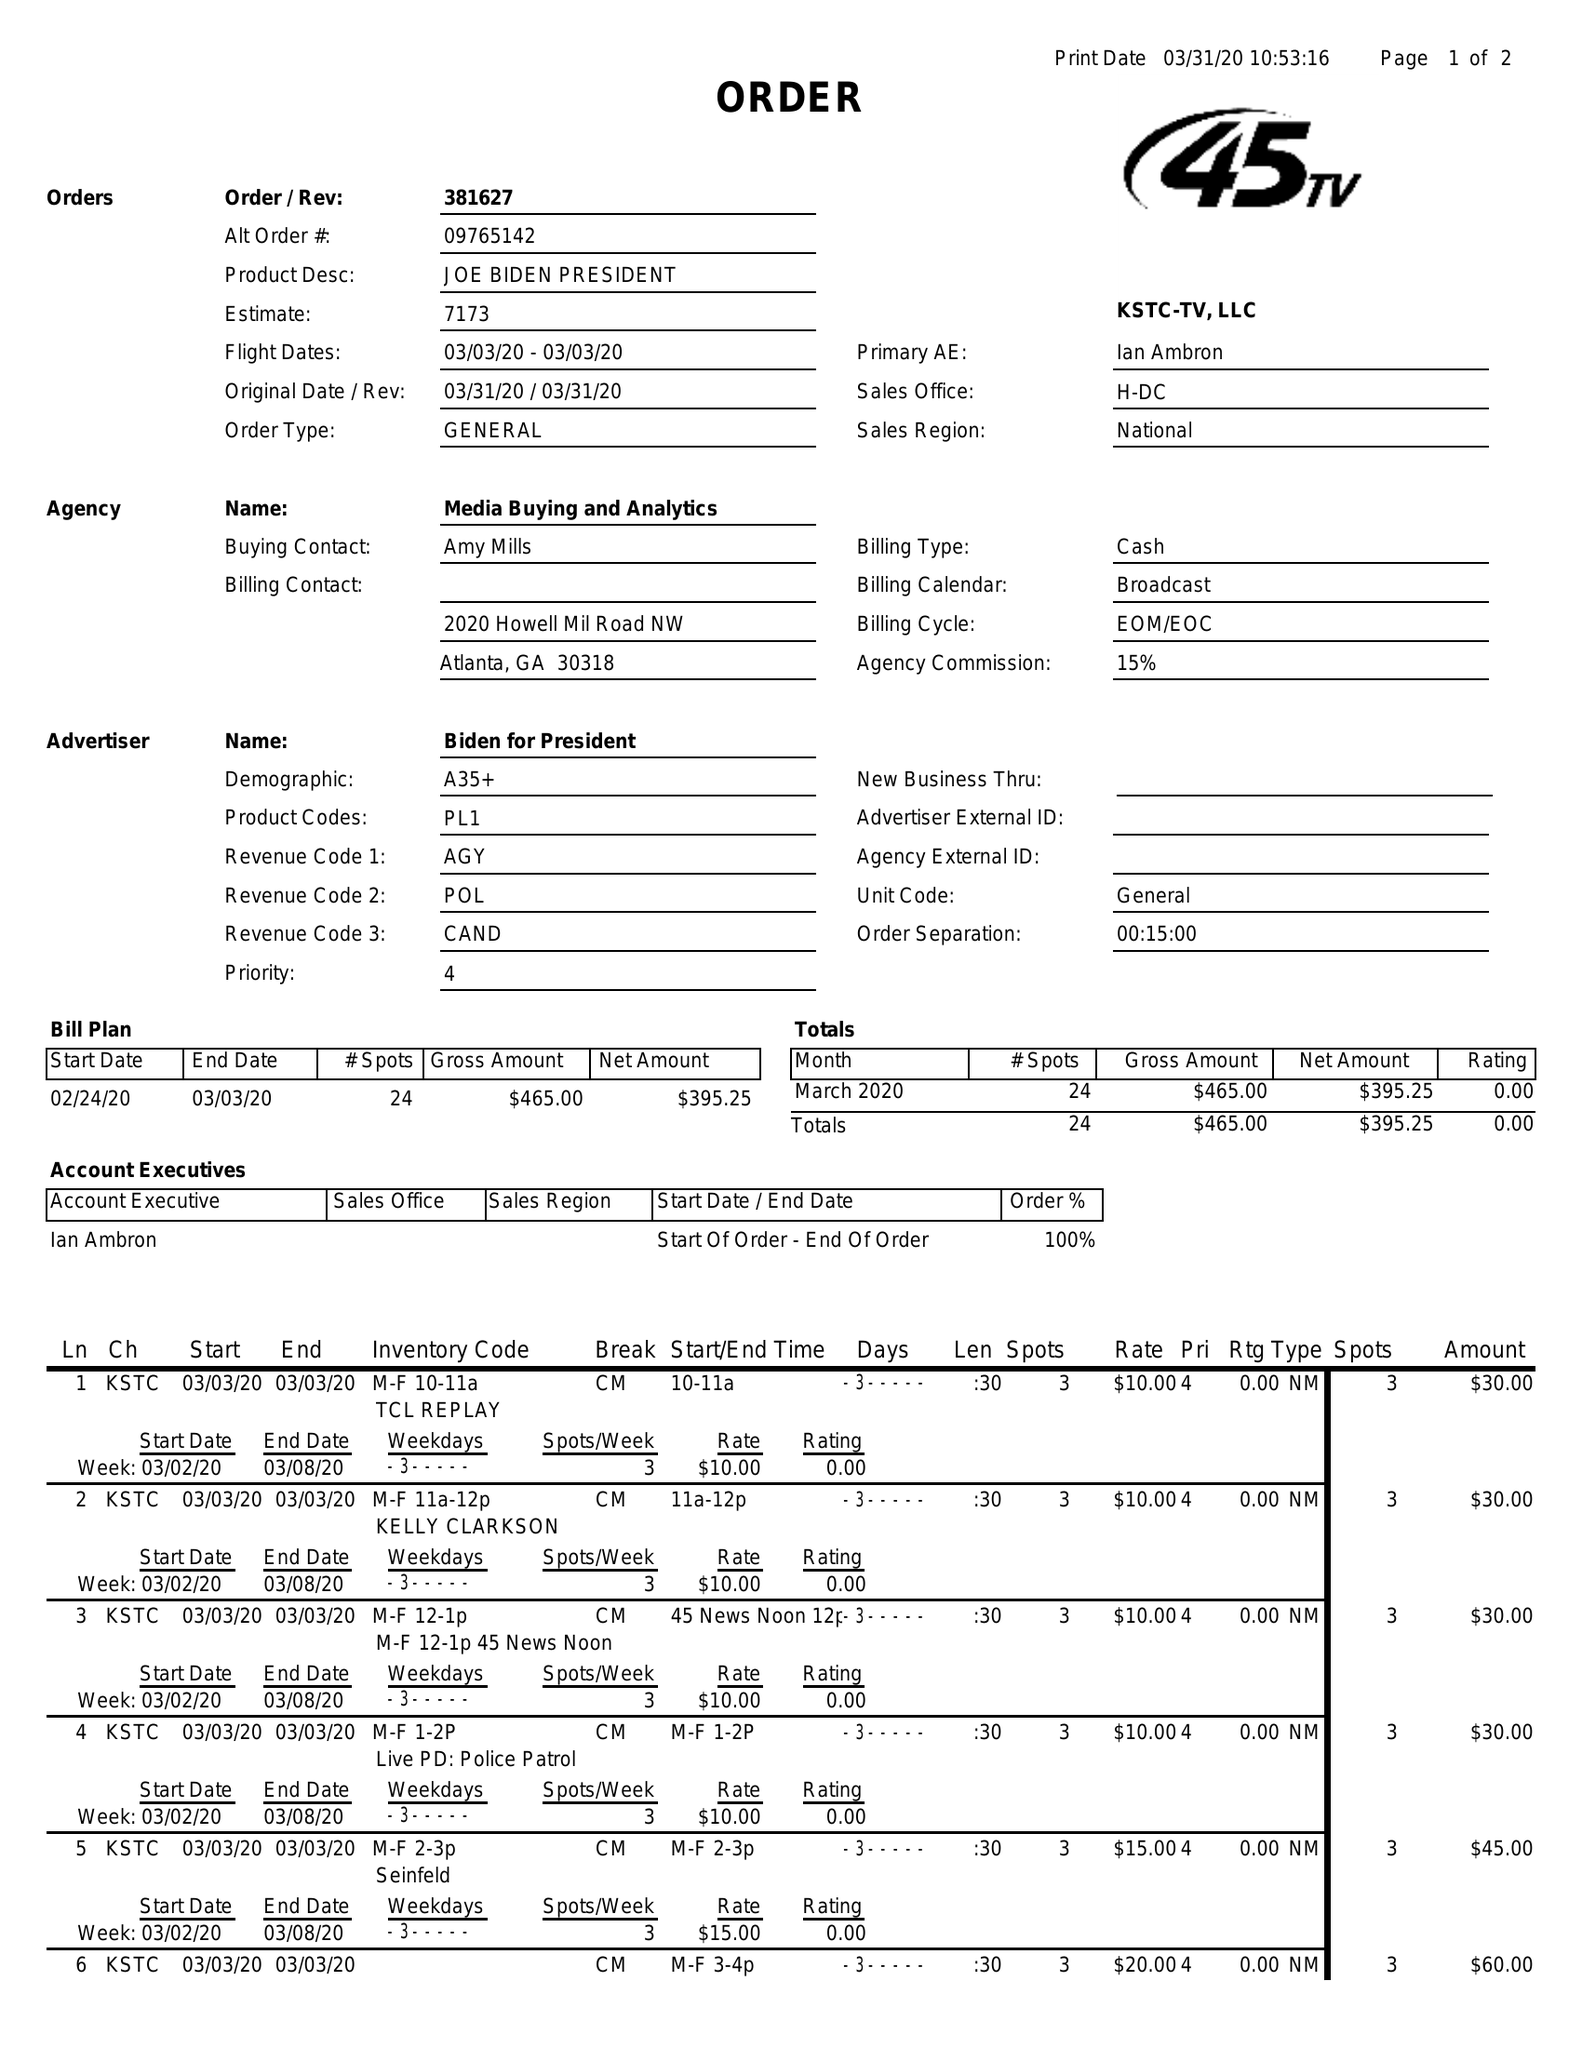What is the value for the gross_amount?
Answer the question using a single word or phrase. 465.00 